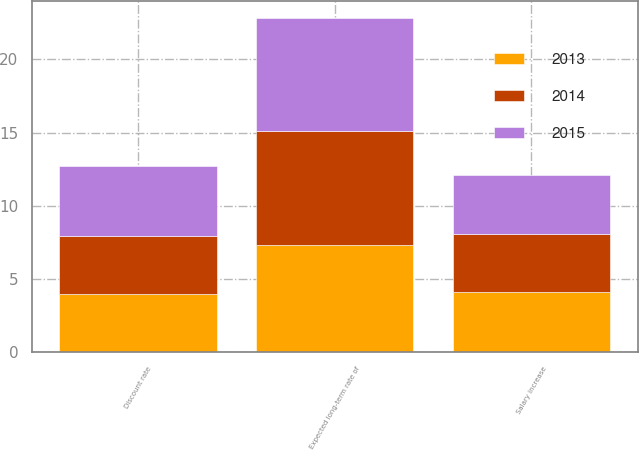Convert chart to OTSL. <chart><loc_0><loc_0><loc_500><loc_500><stacked_bar_chart><ecel><fcel>Discount rate<fcel>Salary increase<fcel>Expected long-term rate of<nl><fcel>2013<fcel>3.95<fcel>4.1<fcel>7.35<nl><fcel>2015<fcel>4.8<fcel>4<fcel>7.75<nl><fcel>2014<fcel>4<fcel>4<fcel>7.75<nl></chart> 